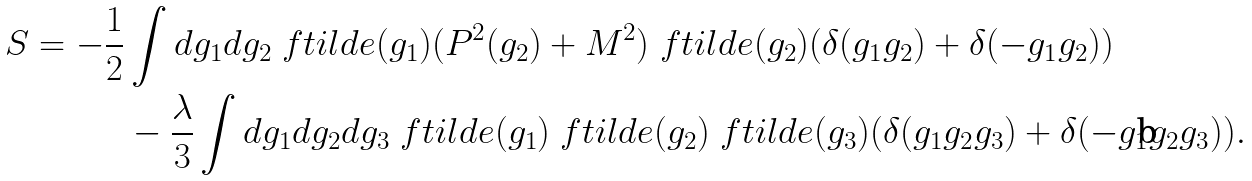<formula> <loc_0><loc_0><loc_500><loc_500>S = - \frac { 1 } { 2 } & \int d g _ { 1 } d g _ { 2 } \ f t i l d e ( g _ { 1 } ) ( P ^ { 2 } ( g _ { 2 } ) + M ^ { 2 } ) \ f t i l d e ( g _ { 2 } ) ( \delta ( g _ { 1 } g _ { 2 } ) + \delta ( - g _ { 1 } g _ { 2 } ) ) \\ & - \frac { \lambda } { 3 } \int d g _ { 1 } d g _ { 2 } d g _ { 3 } \ f t i l d e ( g _ { 1 } ) \ f t i l d e ( g _ { 2 } ) \ f t i l d e ( g _ { 3 } ) ( \delta ( g _ { 1 } g _ { 2 } g _ { 3 } ) + \delta ( - g _ { 1 } g _ { 2 } g _ { 3 } ) ) .</formula> 